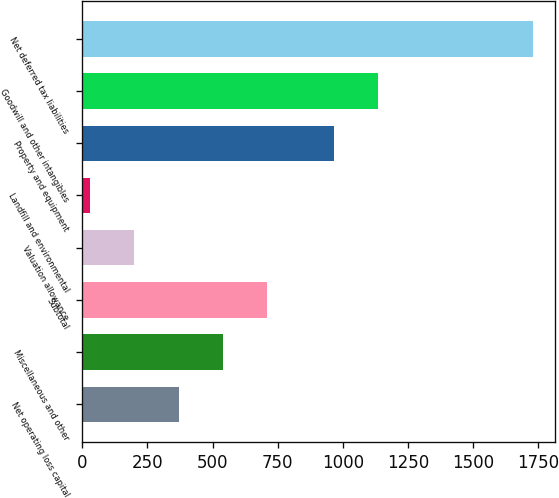<chart> <loc_0><loc_0><loc_500><loc_500><bar_chart><fcel>Net operating loss capital<fcel>Miscellaneous and other<fcel>Subtotal<fcel>Valuation allowance<fcel>Landfill and environmental<fcel>Property and equipment<fcel>Goodwill and other intangibles<fcel>Net deferred tax liabilities<nl><fcel>369.8<fcel>539.7<fcel>709.6<fcel>199.9<fcel>30<fcel>966<fcel>1135.9<fcel>1729<nl></chart> 